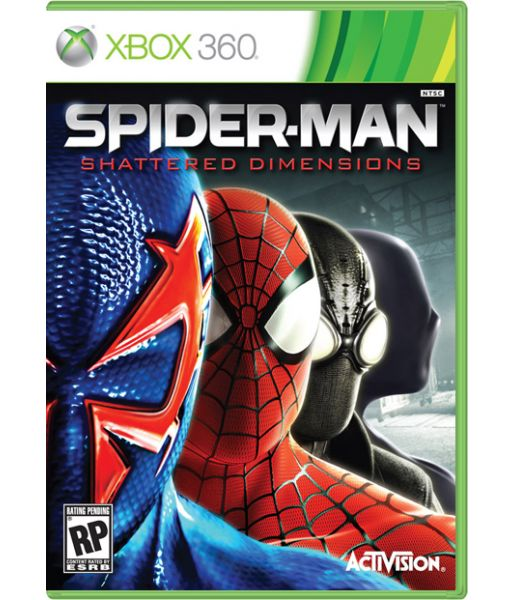What unique gameplay mechanics might each dimension introduce based on the different Spider-Man suits shown on the cover? Based on the different Spider-Man suits shown on the cover, each dimension likely introduces unique gameplay mechanics tailored to the version of Spider-Man it features. For instance, the suit with the futuristic design may offer advanced technology or gadgets, creating a gameplay mechanic centered around futuristic combat and stealth. The traditional red and blue suit might focus on classic web-slinging and acrobatics, emphasizing agility and speed. The dark suit could indicate a stealth-based approach, where shadows and silence play major roles in navigation and combat. These unique mechanics not only vary the gameplay but also offer players a range of experiences, each staying true to the different versions of Spider-Man they control. How might these different mechanics affect the player's experience in terms of difficulty and engagement? The different mechanics introduced by each Spider-Man suit can significantly affect the player's experience in terms of difficulty and engagement. For instance, the futuristic suit with advanced technology may introduce complex, high-paced battles that require quick reflexes and strategic gadget use, raising the difficulty and maintaining high engagement through varied combat scenarios. The traditional suit might deliver a balanced experience focused on agility and classic web-slinging, offering a nostalgic yet challenging gameplay for long-time fans. The stealth-based suit calls for patience and tactical maneuvering, raising the game's difficulty through intricate level designs and enemy patterns, engaging players who enjoy stealth challenges. These diverse mechanics ensure that the gameplay remains fresh and exciting, appealing to a wide range of players and keeping them invested in exploring each dimension thoroughly. 